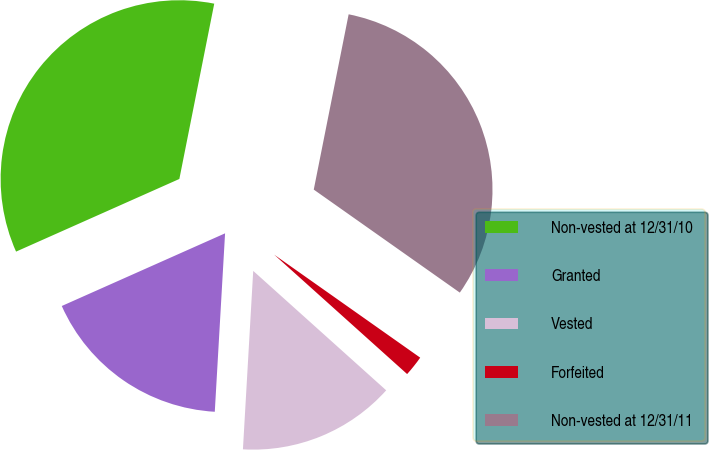Convert chart to OTSL. <chart><loc_0><loc_0><loc_500><loc_500><pie_chart><fcel>Non-vested at 12/31/10<fcel>Granted<fcel>Vested<fcel>Forfeited<fcel>Non-vested at 12/31/11<nl><fcel>34.79%<fcel>17.42%<fcel>14.27%<fcel>1.87%<fcel>31.65%<nl></chart> 